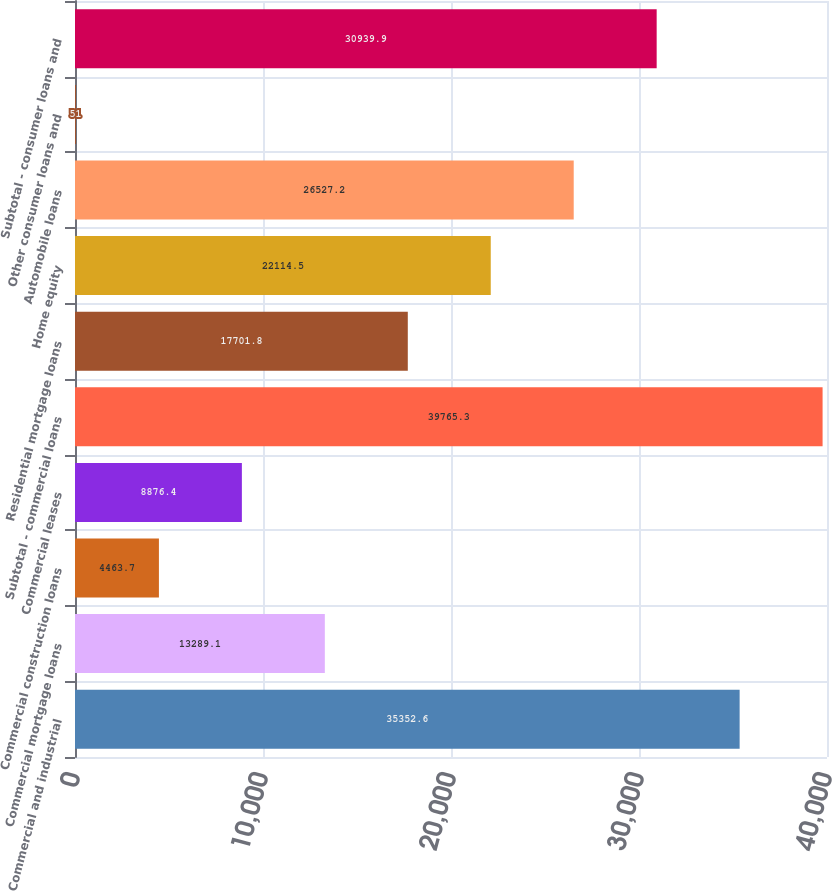<chart> <loc_0><loc_0><loc_500><loc_500><bar_chart><fcel>Commercial and industrial<fcel>Commercial mortgage loans<fcel>Commercial construction loans<fcel>Commercial leases<fcel>Subtotal - commercial loans<fcel>Residential mortgage loans<fcel>Home equity<fcel>Automobile loans<fcel>Other consumer loans and<fcel>Subtotal - consumer loans and<nl><fcel>35352.6<fcel>13289.1<fcel>4463.7<fcel>8876.4<fcel>39765.3<fcel>17701.8<fcel>22114.5<fcel>26527.2<fcel>51<fcel>30939.9<nl></chart> 